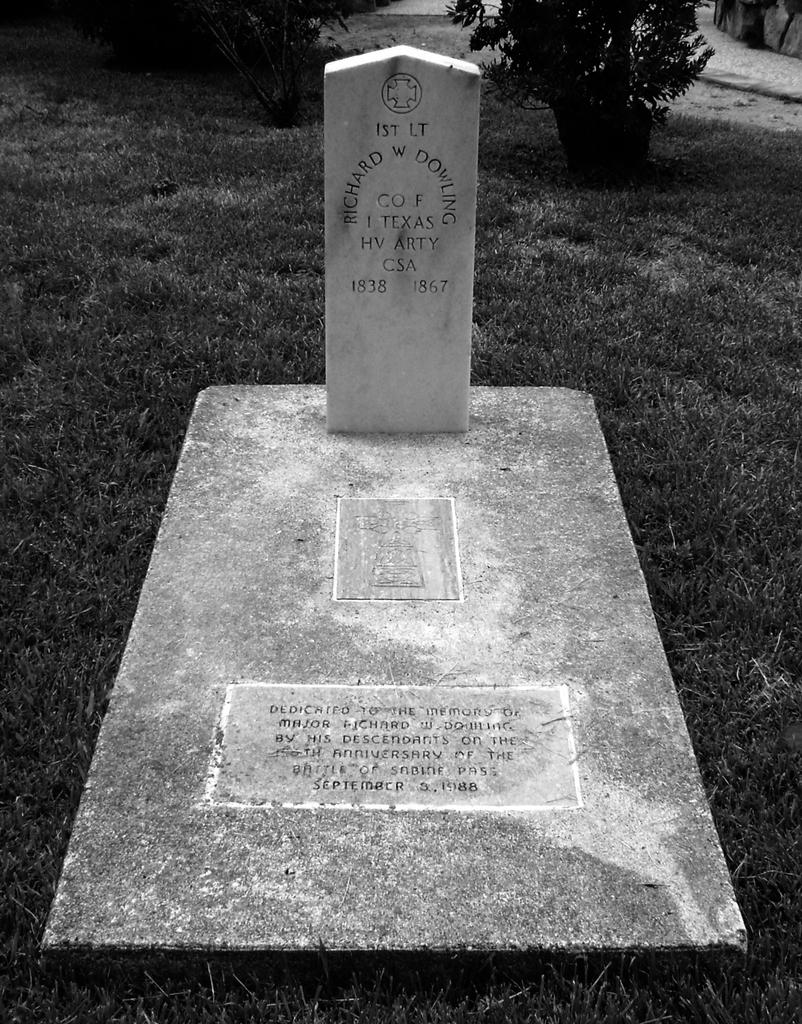What is the color scheme of the image? The image is black and white. What can be seen in the image? There is a grave in the image. Is there any text on the grave? Yes, there is writing on the grave. What is the ground like in the image? There is grass on the ground in the image. What can be seen in the background of the image? There are plants in the background of the image. How much money is being exchanged between the pig and the hospital in the image? There is no pig or hospital present in the image; it features a grave with writing on it. 